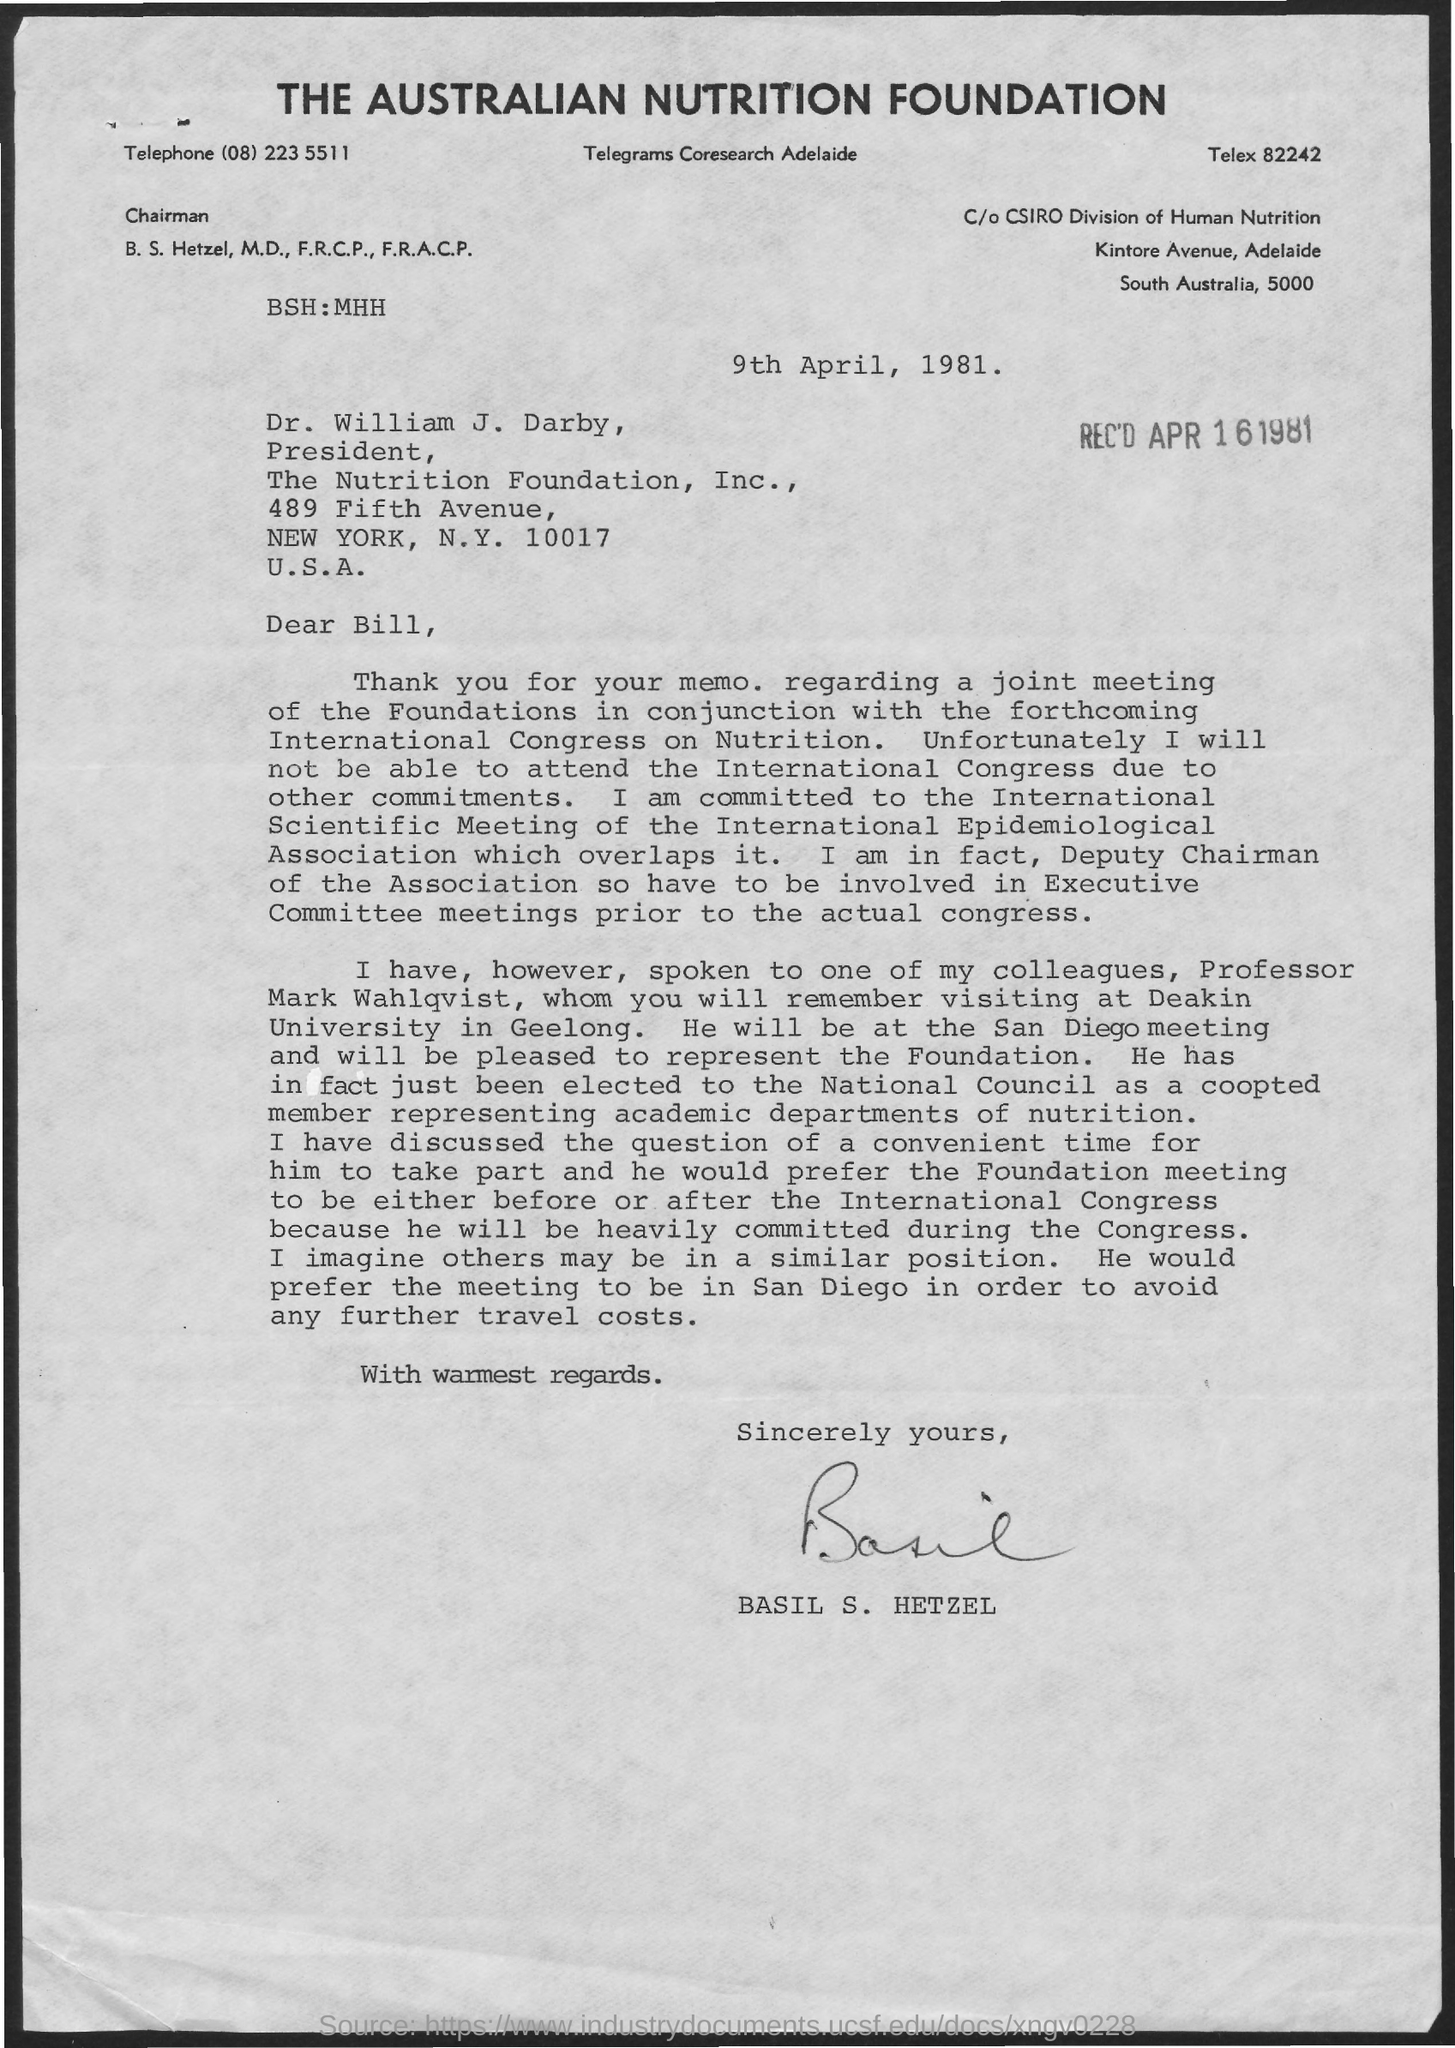Identify some key points in this picture. The telephone number mentioned in the memo is (08) 223 5511. The issued date of this memo is April 9th, 1981. The sender of the memo is Basil S. Hetzel. 